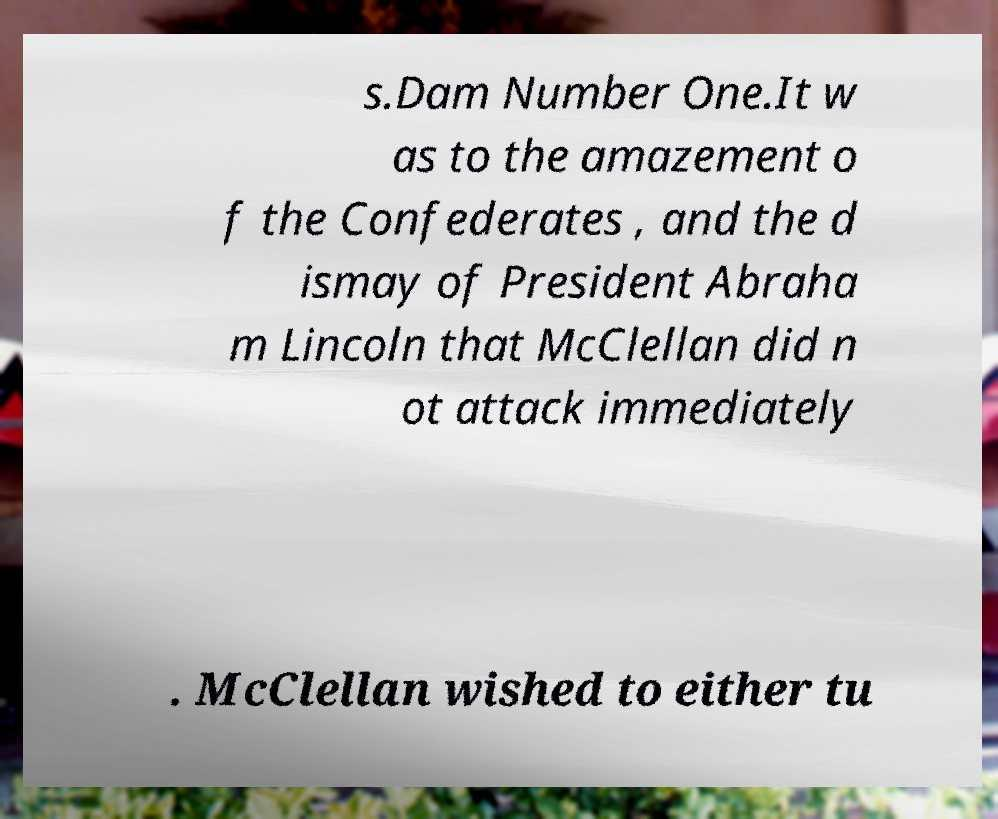For documentation purposes, I need the text within this image transcribed. Could you provide that? s.Dam Number One.It w as to the amazement o f the Confederates , and the d ismay of President Abraha m Lincoln that McClellan did n ot attack immediately . McClellan wished to either tu 